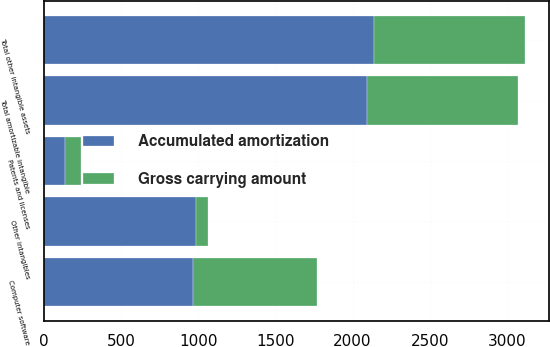Convert chart. <chart><loc_0><loc_0><loc_500><loc_500><stacked_bar_chart><ecel><fcel>Computer software<fcel>Patents and licenses<fcel>Other intangibles<fcel>Total amortizable intangible<fcel>Total other intangible assets<nl><fcel>Accumulated amortization<fcel>969<fcel>135<fcel>988<fcel>2092<fcel>2137<nl><fcel>Gross carrying amount<fcel>801<fcel>104<fcel>74<fcel>979<fcel>979<nl></chart> 